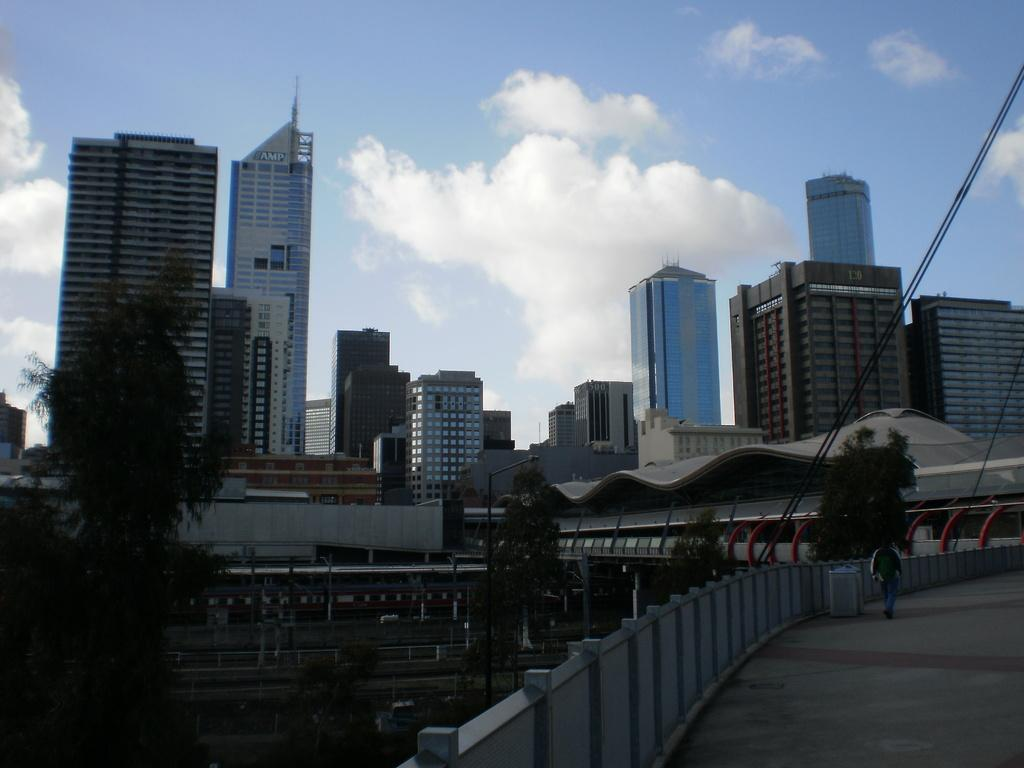What type of structures can be seen in the image? There are buildings and skyscrapers in the image. Can you describe the person in the image? There is a person walking on the road in the image. What are some other objects visible in the image? Street poles, street lights, barrier poles, and trees are present in the image. What can be seen in the sky in the image? The sky is visible in the image, and clouds are visible in the sky. What type of feast is being prepared in the image? There is no mention of a feast or any food preparation in the image. How many bites has the person taken from the street light in the image? There is no indication that the person has interacted with the street light or taken any bites from it in the image. 